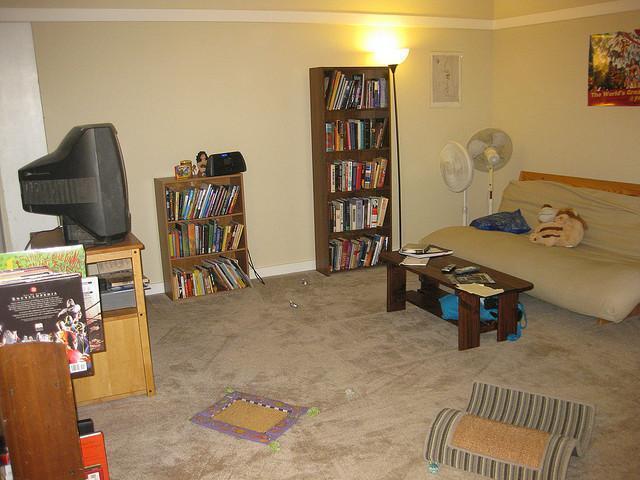How many books are visible?
Give a very brief answer. 2. How many birds are in the tree?
Give a very brief answer. 0. 